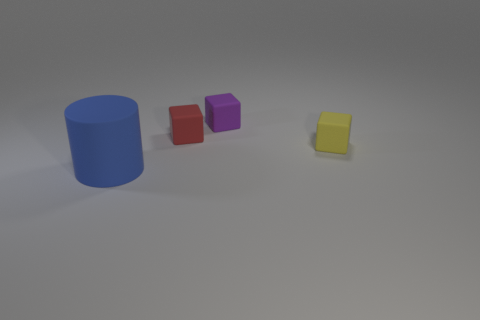What number of things are yellow matte cubes or things behind the big blue object?
Keep it short and to the point. 3. There is a big object; what shape is it?
Ensure brevity in your answer.  Cylinder. There is a tiny matte thing to the right of the tiny matte cube that is behind the red rubber block; what is its shape?
Offer a very short reply. Cube. There is a large cylinder that is the same material as the tiny red block; what is its color?
Give a very brief answer. Blue. Is there any other thing that is the same size as the purple rubber object?
Make the answer very short. Yes. There is a rubber object in front of the yellow block; is it the same color as the thing behind the small red rubber block?
Keep it short and to the point. No. Are there more yellow rubber things on the left side of the purple matte thing than cylinders in front of the large rubber cylinder?
Ensure brevity in your answer.  No. Is there anything else that is the same shape as the small red thing?
Your answer should be very brief. Yes. Does the big blue matte object have the same shape as the small thing on the left side of the purple block?
Ensure brevity in your answer.  No. What number of other things are there of the same material as the yellow thing
Your answer should be compact. 3. 